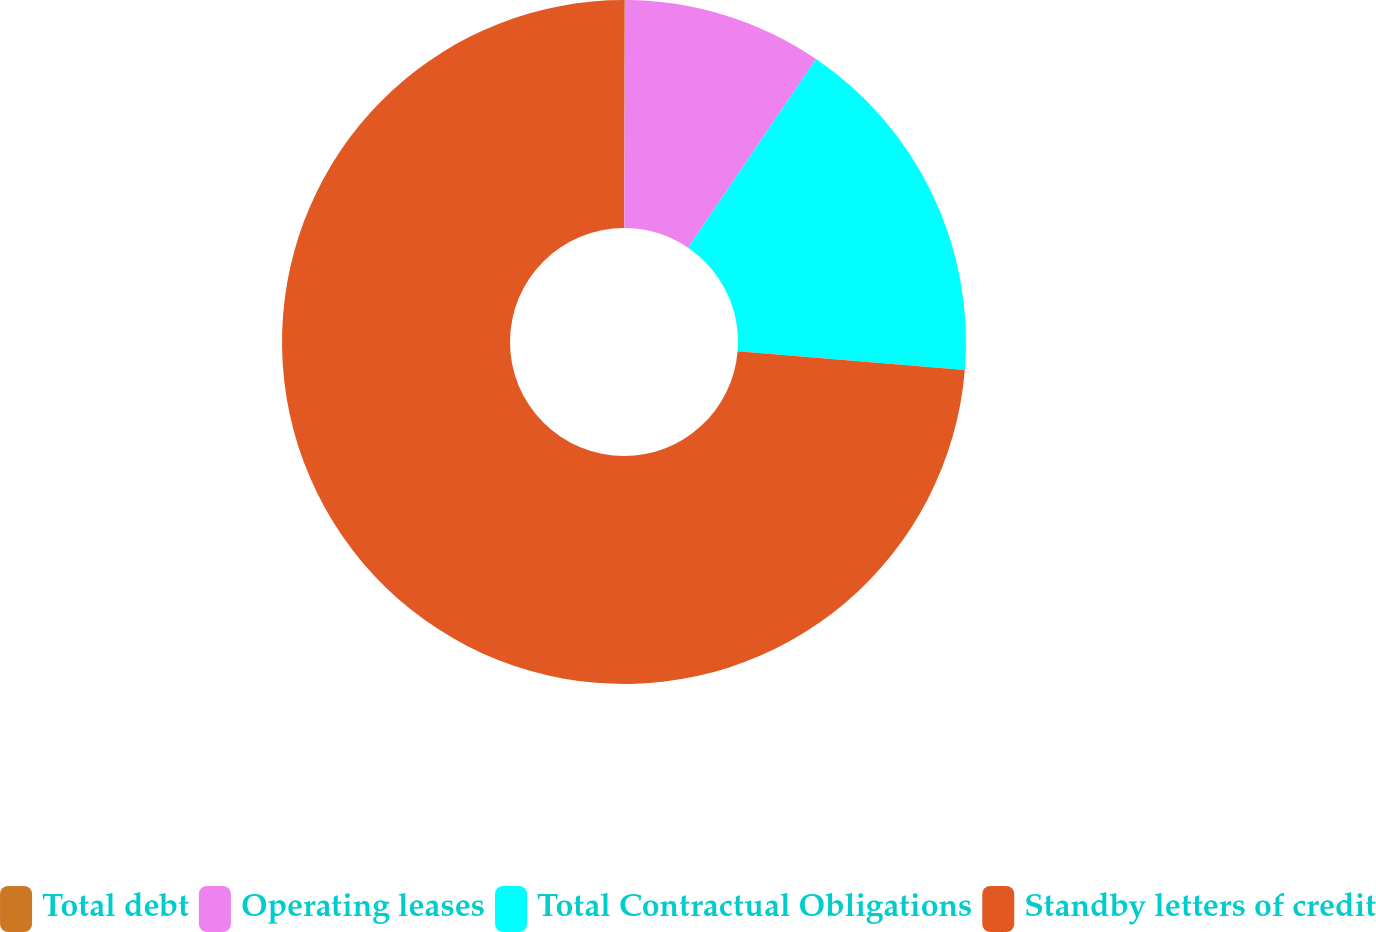<chart> <loc_0><loc_0><loc_500><loc_500><pie_chart><fcel>Total debt<fcel>Operating leases<fcel>Total Contractual Obligations<fcel>Standby letters of credit<nl><fcel>0.04%<fcel>9.45%<fcel>16.82%<fcel>73.69%<nl></chart> 